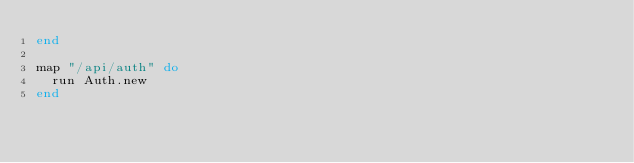<code> <loc_0><loc_0><loc_500><loc_500><_Ruby_>end

map "/api/auth" do
  run Auth.new
end
</code> 